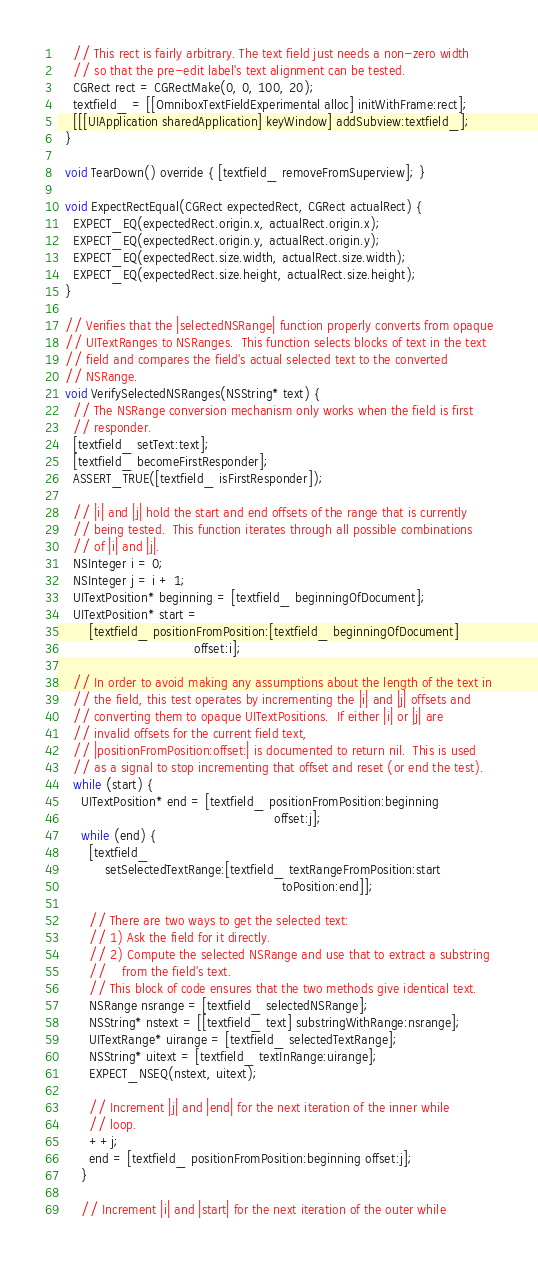Convert code to text. <code><loc_0><loc_0><loc_500><loc_500><_ObjectiveC_>    // This rect is fairly arbitrary. The text field just needs a non-zero width
    // so that the pre-edit label's text alignment can be tested.
    CGRect rect = CGRectMake(0, 0, 100, 20);
    textfield_ = [[OmniboxTextFieldExperimental alloc] initWithFrame:rect];
    [[[UIApplication sharedApplication] keyWindow] addSubview:textfield_];
  }

  void TearDown() override { [textfield_ removeFromSuperview]; }

  void ExpectRectEqual(CGRect expectedRect, CGRect actualRect) {
    EXPECT_EQ(expectedRect.origin.x, actualRect.origin.x);
    EXPECT_EQ(expectedRect.origin.y, actualRect.origin.y);
    EXPECT_EQ(expectedRect.size.width, actualRect.size.width);
    EXPECT_EQ(expectedRect.size.height, actualRect.size.height);
  }

  // Verifies that the |selectedNSRange| function properly converts from opaque
  // UITextRanges to NSRanges.  This function selects blocks of text in the text
  // field and compares the field's actual selected text to the converted
  // NSRange.
  void VerifySelectedNSRanges(NSString* text) {
    // The NSRange conversion mechanism only works when the field is first
    // responder.
    [textfield_ setText:text];
    [textfield_ becomeFirstResponder];
    ASSERT_TRUE([textfield_ isFirstResponder]);

    // |i| and |j| hold the start and end offsets of the range that is currently
    // being tested.  This function iterates through all possible combinations
    // of |i| and |j|.
    NSInteger i = 0;
    NSInteger j = i + 1;
    UITextPosition* beginning = [textfield_ beginningOfDocument];
    UITextPosition* start =
        [textfield_ positionFromPosition:[textfield_ beginningOfDocument]
                                  offset:i];

    // In order to avoid making any assumptions about the length of the text in
    // the field, this test operates by incrementing the |i| and |j| offsets and
    // converting them to opaque UITextPositions.  If either |i| or |j| are
    // invalid offsets for the current field text,
    // |positionFromPosition:offset:| is documented to return nil.  This is used
    // as a signal to stop incrementing that offset and reset (or end the test).
    while (start) {
      UITextPosition* end = [textfield_ positionFromPosition:beginning
                                                      offset:j];
      while (end) {
        [textfield_
            setSelectedTextRange:[textfield_ textRangeFromPosition:start
                                                        toPosition:end]];

        // There are two ways to get the selected text:
        // 1) Ask the field for it directly.
        // 2) Compute the selected NSRange and use that to extract a substring
        //    from the field's text.
        // This block of code ensures that the two methods give identical text.
        NSRange nsrange = [textfield_ selectedNSRange];
        NSString* nstext = [[textfield_ text] substringWithRange:nsrange];
        UITextRange* uirange = [textfield_ selectedTextRange];
        NSString* uitext = [textfield_ textInRange:uirange];
        EXPECT_NSEQ(nstext, uitext);

        // Increment |j| and |end| for the next iteration of the inner while
        // loop.
        ++j;
        end = [textfield_ positionFromPosition:beginning offset:j];
      }

      // Increment |i| and |start| for the next iteration of the outer while</code> 